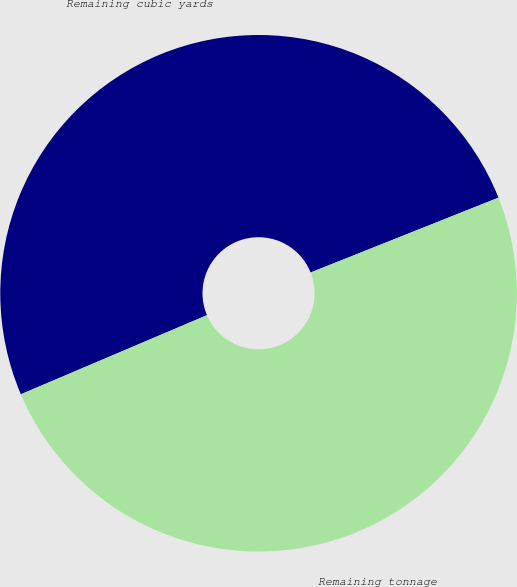Convert chart. <chart><loc_0><loc_0><loc_500><loc_500><pie_chart><fcel>Remaining cubic yards<fcel>Remaining tonnage<nl><fcel>50.36%<fcel>49.64%<nl></chart> 